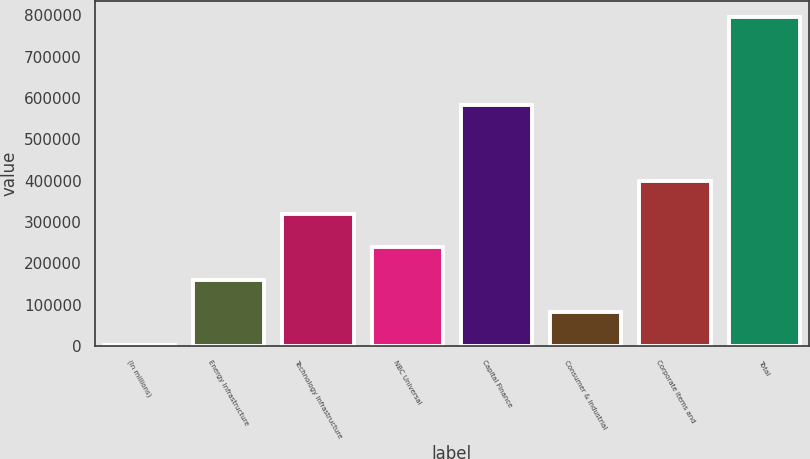Convert chart to OTSL. <chart><loc_0><loc_0><loc_500><loc_500><bar_chart><fcel>(In millions)<fcel>Energy Infrastructure<fcel>Technology Infrastructure<fcel>NBC Universal<fcel>Capital Finance<fcel>Consumer & Industrial<fcel>Corporate items and<fcel>Total<nl><fcel>2007<fcel>160742<fcel>319477<fcel>240110<fcel>583965<fcel>81374.6<fcel>398845<fcel>795683<nl></chart> 